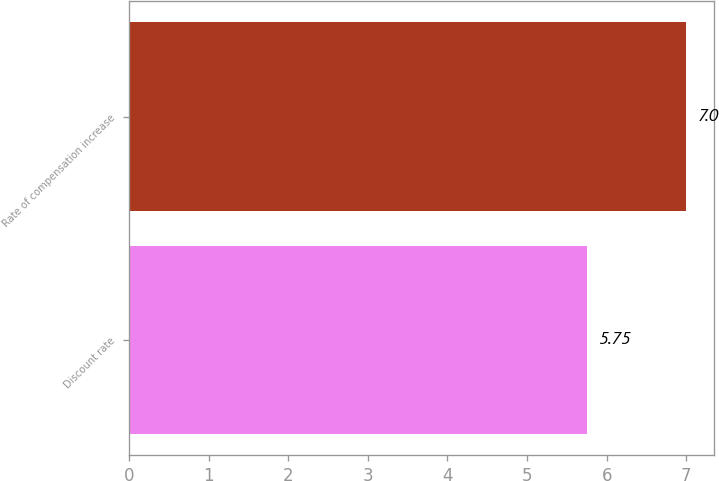<chart> <loc_0><loc_0><loc_500><loc_500><bar_chart><fcel>Discount rate<fcel>Rate of compensation increase<nl><fcel>5.75<fcel>7<nl></chart> 